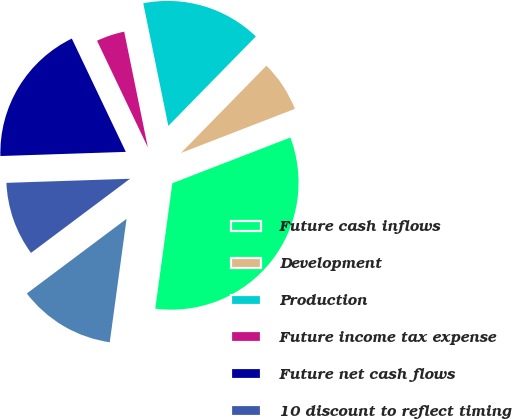<chart> <loc_0><loc_0><loc_500><loc_500><pie_chart><fcel>Future cash inflows<fcel>Development<fcel>Production<fcel>Future income tax expense<fcel>Future net cash flows<fcel>10 discount to reflect timing<fcel>Standardized measure of<nl><fcel>33.04%<fcel>6.79%<fcel>15.54%<fcel>3.87%<fcel>18.45%<fcel>9.7%<fcel>12.62%<nl></chart> 